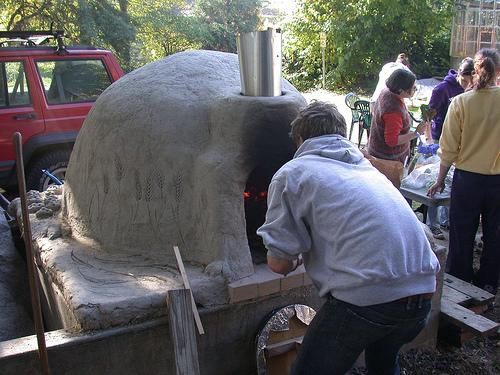What is the main piece of outdoor furniture that can be seen in the image? A green plastic chair is the most noticeable piece of outdoor furniture in the image. What type of oven is present in the image and what color is it? A large grey clay oven with wheat designs and an exhaust pipe is present in the image. Describe the type of stove being used outdoors and any additional objects around it. It is a large grey clay oven with wheat designs, an exhaust pipe, and a wooden stick leaning against the stove. Mention the clothing and colors of at least two people present in the image. One woman is wearing a yellow sweater, and another woman is sporting a purple top. Point out any significant detail related to the clay oven. The clay oven has an exhaust pipe made of silver-colored metal and has burning red coals inside. In a single sentence, provide a brief overview of the scene displayed in the image. A lively outdoor scene with people gathering around a table, a red car parked near a grey clay oven with burning coals, and green plastic chairs in the background. Describe the people you see gathered around a particular object in the image. A group of women is seated at a table and engaged in conversation, with one woman wearing a yellow sweater and another wearing a purple top. Mention the color and position of the car seen in the image. The car is red in color and is parked on the left side of the clay oven. Provide a brief description of the key objects present in the image. A tree, a red car, a clay oven, a bench, a group of people, a woman in a yellow sweater, a man in a grey hoodie, and green plastic chairs. Describe the position and appearance of the tree in the image. The tall tree stands near the top-left corner of the image, and its leaves exhibit a vibrant green color. 